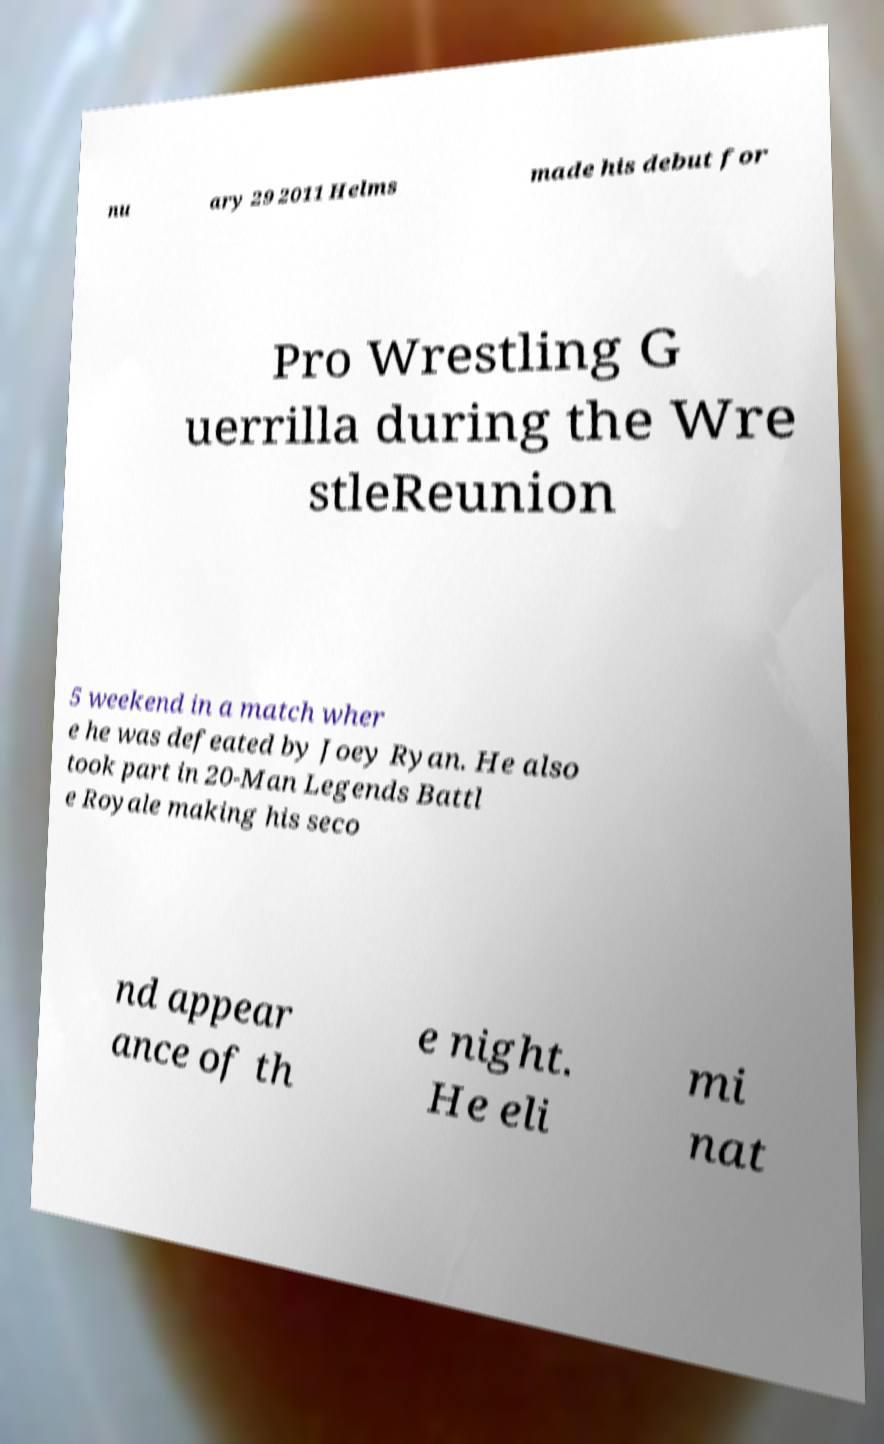Please identify and transcribe the text found in this image. nu ary 29 2011 Helms made his debut for Pro Wrestling G uerrilla during the Wre stleReunion 5 weekend in a match wher e he was defeated by Joey Ryan. He also took part in 20-Man Legends Battl e Royale making his seco nd appear ance of th e night. He eli mi nat 